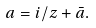<formula> <loc_0><loc_0><loc_500><loc_500>a = i / z + \bar { a } .</formula> 